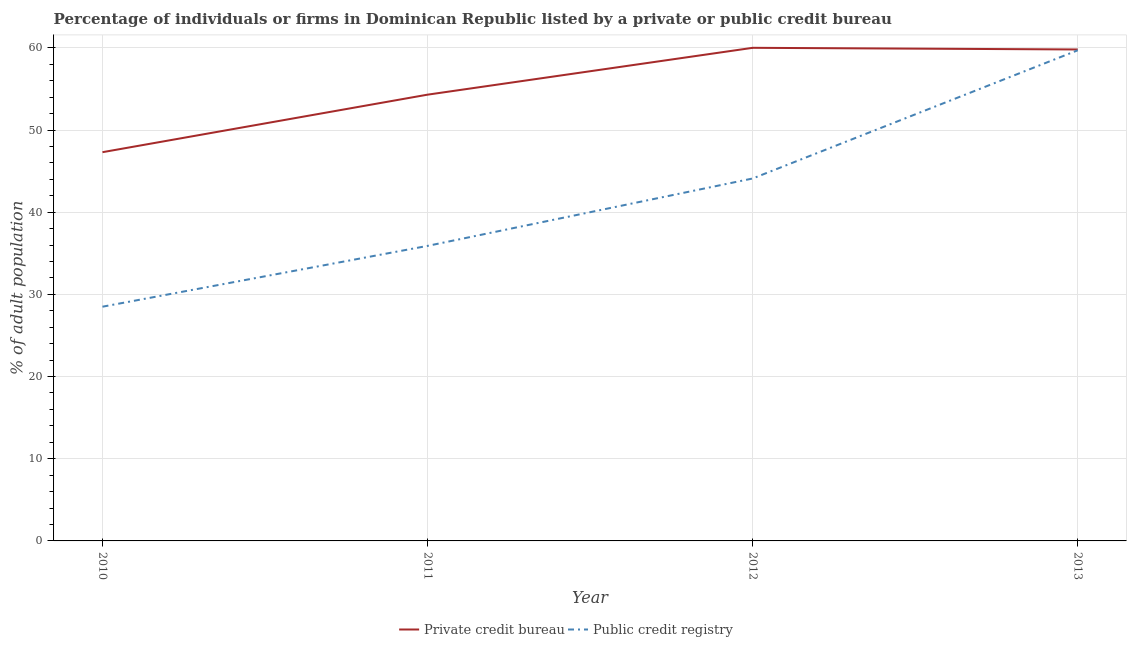How many different coloured lines are there?
Provide a short and direct response. 2. Does the line corresponding to percentage of firms listed by private credit bureau intersect with the line corresponding to percentage of firms listed by public credit bureau?
Provide a succinct answer. No. Is the number of lines equal to the number of legend labels?
Provide a short and direct response. Yes. What is the percentage of firms listed by private credit bureau in 2011?
Your answer should be very brief. 54.3. Across all years, what is the maximum percentage of firms listed by public credit bureau?
Your answer should be very brief. 59.7. What is the total percentage of firms listed by public credit bureau in the graph?
Ensure brevity in your answer.  168.2. What is the difference between the percentage of firms listed by public credit bureau in 2012 and that in 2013?
Your answer should be very brief. -15.6. What is the difference between the percentage of firms listed by private credit bureau in 2011 and the percentage of firms listed by public credit bureau in 2013?
Provide a short and direct response. -5.4. What is the average percentage of firms listed by public credit bureau per year?
Make the answer very short. 42.05. In the year 2013, what is the difference between the percentage of firms listed by private credit bureau and percentage of firms listed by public credit bureau?
Your answer should be very brief. 0.1. What is the ratio of the percentage of firms listed by private credit bureau in 2011 to that in 2013?
Your answer should be very brief. 0.91. What is the difference between the highest and the second highest percentage of firms listed by public credit bureau?
Keep it short and to the point. 15.6. What is the difference between the highest and the lowest percentage of firms listed by public credit bureau?
Ensure brevity in your answer.  31.2. Is the sum of the percentage of firms listed by private credit bureau in 2011 and 2012 greater than the maximum percentage of firms listed by public credit bureau across all years?
Your response must be concise. Yes. Is the percentage of firms listed by private credit bureau strictly less than the percentage of firms listed by public credit bureau over the years?
Offer a very short reply. No. How many years are there in the graph?
Your response must be concise. 4. What is the difference between two consecutive major ticks on the Y-axis?
Ensure brevity in your answer.  10. Where does the legend appear in the graph?
Provide a short and direct response. Bottom center. How many legend labels are there?
Keep it short and to the point. 2. What is the title of the graph?
Offer a very short reply. Percentage of individuals or firms in Dominican Republic listed by a private or public credit bureau. What is the label or title of the Y-axis?
Give a very brief answer. % of adult population. What is the % of adult population of Private credit bureau in 2010?
Make the answer very short. 47.3. What is the % of adult population of Private credit bureau in 2011?
Offer a terse response. 54.3. What is the % of adult population of Public credit registry in 2011?
Your answer should be very brief. 35.9. What is the % of adult population in Public credit registry in 2012?
Provide a succinct answer. 44.1. What is the % of adult population of Private credit bureau in 2013?
Ensure brevity in your answer.  59.8. What is the % of adult population in Public credit registry in 2013?
Make the answer very short. 59.7. Across all years, what is the maximum % of adult population in Private credit bureau?
Your answer should be compact. 60. Across all years, what is the maximum % of adult population of Public credit registry?
Offer a very short reply. 59.7. Across all years, what is the minimum % of adult population of Private credit bureau?
Keep it short and to the point. 47.3. What is the total % of adult population in Private credit bureau in the graph?
Make the answer very short. 221.4. What is the total % of adult population in Public credit registry in the graph?
Give a very brief answer. 168.2. What is the difference between the % of adult population of Public credit registry in 2010 and that in 2011?
Your answer should be very brief. -7.4. What is the difference between the % of adult population of Private credit bureau in 2010 and that in 2012?
Provide a short and direct response. -12.7. What is the difference between the % of adult population in Public credit registry in 2010 and that in 2012?
Make the answer very short. -15.6. What is the difference between the % of adult population in Public credit registry in 2010 and that in 2013?
Your response must be concise. -31.2. What is the difference between the % of adult population in Public credit registry in 2011 and that in 2012?
Your answer should be compact. -8.2. What is the difference between the % of adult population in Public credit registry in 2011 and that in 2013?
Make the answer very short. -23.8. What is the difference between the % of adult population of Private credit bureau in 2012 and that in 2013?
Provide a short and direct response. 0.2. What is the difference between the % of adult population of Public credit registry in 2012 and that in 2013?
Give a very brief answer. -15.6. What is the difference between the % of adult population of Private credit bureau in 2011 and the % of adult population of Public credit registry in 2012?
Make the answer very short. 10.2. What is the difference between the % of adult population in Private credit bureau in 2011 and the % of adult population in Public credit registry in 2013?
Your answer should be compact. -5.4. What is the difference between the % of adult population in Private credit bureau in 2012 and the % of adult population in Public credit registry in 2013?
Provide a succinct answer. 0.3. What is the average % of adult population in Private credit bureau per year?
Your answer should be very brief. 55.35. What is the average % of adult population in Public credit registry per year?
Your answer should be very brief. 42.05. In the year 2010, what is the difference between the % of adult population of Private credit bureau and % of adult population of Public credit registry?
Provide a short and direct response. 18.8. In the year 2013, what is the difference between the % of adult population in Private credit bureau and % of adult population in Public credit registry?
Make the answer very short. 0.1. What is the ratio of the % of adult population of Private credit bureau in 2010 to that in 2011?
Offer a very short reply. 0.87. What is the ratio of the % of adult population in Public credit registry in 2010 to that in 2011?
Keep it short and to the point. 0.79. What is the ratio of the % of adult population in Private credit bureau in 2010 to that in 2012?
Make the answer very short. 0.79. What is the ratio of the % of adult population in Public credit registry in 2010 to that in 2012?
Your answer should be very brief. 0.65. What is the ratio of the % of adult population of Private credit bureau in 2010 to that in 2013?
Provide a succinct answer. 0.79. What is the ratio of the % of adult population in Public credit registry in 2010 to that in 2013?
Give a very brief answer. 0.48. What is the ratio of the % of adult population of Private credit bureau in 2011 to that in 2012?
Your answer should be compact. 0.91. What is the ratio of the % of adult population in Public credit registry in 2011 to that in 2012?
Offer a terse response. 0.81. What is the ratio of the % of adult population of Private credit bureau in 2011 to that in 2013?
Give a very brief answer. 0.91. What is the ratio of the % of adult population of Public credit registry in 2011 to that in 2013?
Offer a very short reply. 0.6. What is the ratio of the % of adult population in Public credit registry in 2012 to that in 2013?
Ensure brevity in your answer.  0.74. What is the difference between the highest and the second highest % of adult population of Private credit bureau?
Offer a very short reply. 0.2. What is the difference between the highest and the second highest % of adult population of Public credit registry?
Provide a succinct answer. 15.6. What is the difference between the highest and the lowest % of adult population of Private credit bureau?
Your answer should be compact. 12.7. What is the difference between the highest and the lowest % of adult population in Public credit registry?
Make the answer very short. 31.2. 